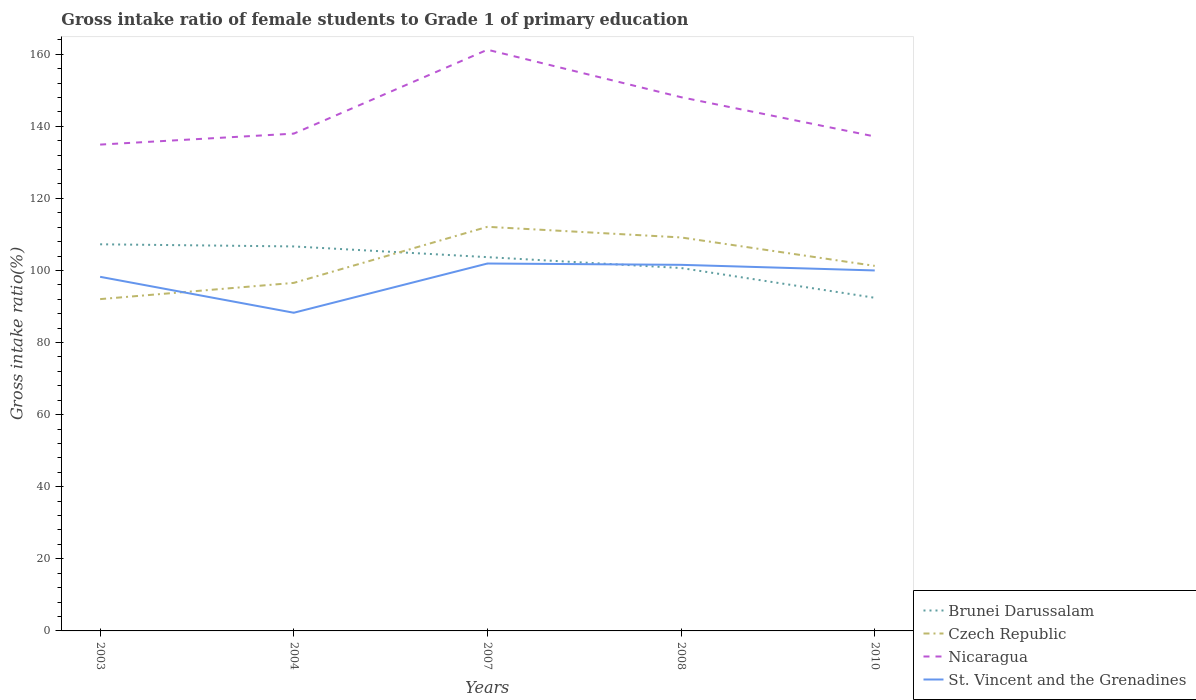Does the line corresponding to Brunei Darussalam intersect with the line corresponding to St. Vincent and the Grenadines?
Keep it short and to the point. Yes. Is the number of lines equal to the number of legend labels?
Offer a very short reply. Yes. Across all years, what is the maximum gross intake ratio in Nicaragua?
Your answer should be very brief. 134.92. What is the total gross intake ratio in Nicaragua in the graph?
Make the answer very short. 10.9. What is the difference between the highest and the second highest gross intake ratio in Nicaragua?
Keep it short and to the point. 26.32. Is the gross intake ratio in Brunei Darussalam strictly greater than the gross intake ratio in Czech Republic over the years?
Provide a short and direct response. No. How many lines are there?
Offer a very short reply. 4. What is the difference between two consecutive major ticks on the Y-axis?
Ensure brevity in your answer.  20. Does the graph contain grids?
Make the answer very short. No. How are the legend labels stacked?
Offer a very short reply. Vertical. What is the title of the graph?
Provide a short and direct response. Gross intake ratio of female students to Grade 1 of primary education. Does "Lao PDR" appear as one of the legend labels in the graph?
Provide a succinct answer. No. What is the label or title of the X-axis?
Keep it short and to the point. Years. What is the label or title of the Y-axis?
Your response must be concise. Gross intake ratio(%). What is the Gross intake ratio(%) in Brunei Darussalam in 2003?
Provide a short and direct response. 107.26. What is the Gross intake ratio(%) of Czech Republic in 2003?
Your response must be concise. 92.05. What is the Gross intake ratio(%) of Nicaragua in 2003?
Give a very brief answer. 134.92. What is the Gross intake ratio(%) of St. Vincent and the Grenadines in 2003?
Keep it short and to the point. 98.24. What is the Gross intake ratio(%) of Brunei Darussalam in 2004?
Make the answer very short. 106.66. What is the Gross intake ratio(%) in Czech Republic in 2004?
Give a very brief answer. 96.55. What is the Gross intake ratio(%) in Nicaragua in 2004?
Your response must be concise. 137.96. What is the Gross intake ratio(%) in St. Vincent and the Grenadines in 2004?
Offer a very short reply. 88.27. What is the Gross intake ratio(%) in Brunei Darussalam in 2007?
Your answer should be compact. 103.69. What is the Gross intake ratio(%) in Czech Republic in 2007?
Keep it short and to the point. 112.11. What is the Gross intake ratio(%) in Nicaragua in 2007?
Provide a succinct answer. 161.24. What is the Gross intake ratio(%) in St. Vincent and the Grenadines in 2007?
Keep it short and to the point. 101.93. What is the Gross intake ratio(%) of Brunei Darussalam in 2008?
Your answer should be compact. 100.68. What is the Gross intake ratio(%) of Czech Republic in 2008?
Provide a succinct answer. 109.16. What is the Gross intake ratio(%) in Nicaragua in 2008?
Your answer should be very brief. 148.06. What is the Gross intake ratio(%) of St. Vincent and the Grenadines in 2008?
Provide a succinct answer. 101.56. What is the Gross intake ratio(%) of Brunei Darussalam in 2010?
Your answer should be compact. 92.42. What is the Gross intake ratio(%) in Czech Republic in 2010?
Your answer should be very brief. 101.27. What is the Gross intake ratio(%) in Nicaragua in 2010?
Make the answer very short. 137.17. Across all years, what is the maximum Gross intake ratio(%) in Brunei Darussalam?
Your response must be concise. 107.26. Across all years, what is the maximum Gross intake ratio(%) in Czech Republic?
Your answer should be very brief. 112.11. Across all years, what is the maximum Gross intake ratio(%) of Nicaragua?
Make the answer very short. 161.24. Across all years, what is the maximum Gross intake ratio(%) of St. Vincent and the Grenadines?
Offer a terse response. 101.93. Across all years, what is the minimum Gross intake ratio(%) of Brunei Darussalam?
Keep it short and to the point. 92.42. Across all years, what is the minimum Gross intake ratio(%) of Czech Republic?
Give a very brief answer. 92.05. Across all years, what is the minimum Gross intake ratio(%) in Nicaragua?
Your answer should be compact. 134.92. Across all years, what is the minimum Gross intake ratio(%) in St. Vincent and the Grenadines?
Your response must be concise. 88.27. What is the total Gross intake ratio(%) of Brunei Darussalam in the graph?
Your answer should be very brief. 510.71. What is the total Gross intake ratio(%) in Czech Republic in the graph?
Offer a very short reply. 511.14. What is the total Gross intake ratio(%) of Nicaragua in the graph?
Give a very brief answer. 719.34. What is the total Gross intake ratio(%) in St. Vincent and the Grenadines in the graph?
Make the answer very short. 489.99. What is the difference between the Gross intake ratio(%) of Brunei Darussalam in 2003 and that in 2004?
Your answer should be very brief. 0.59. What is the difference between the Gross intake ratio(%) of Czech Republic in 2003 and that in 2004?
Provide a short and direct response. -4.5. What is the difference between the Gross intake ratio(%) in Nicaragua in 2003 and that in 2004?
Provide a succinct answer. -3.04. What is the difference between the Gross intake ratio(%) of St. Vincent and the Grenadines in 2003 and that in 2004?
Ensure brevity in your answer.  9.97. What is the difference between the Gross intake ratio(%) in Brunei Darussalam in 2003 and that in 2007?
Provide a short and direct response. 3.56. What is the difference between the Gross intake ratio(%) of Czech Republic in 2003 and that in 2007?
Keep it short and to the point. -20.06. What is the difference between the Gross intake ratio(%) in Nicaragua in 2003 and that in 2007?
Your answer should be compact. -26.32. What is the difference between the Gross intake ratio(%) of St. Vincent and the Grenadines in 2003 and that in 2007?
Your answer should be compact. -3.69. What is the difference between the Gross intake ratio(%) of Brunei Darussalam in 2003 and that in 2008?
Keep it short and to the point. 6.58. What is the difference between the Gross intake ratio(%) of Czech Republic in 2003 and that in 2008?
Provide a succinct answer. -17.11. What is the difference between the Gross intake ratio(%) of Nicaragua in 2003 and that in 2008?
Offer a terse response. -13.15. What is the difference between the Gross intake ratio(%) in St. Vincent and the Grenadines in 2003 and that in 2008?
Your answer should be compact. -3.32. What is the difference between the Gross intake ratio(%) in Brunei Darussalam in 2003 and that in 2010?
Your answer should be very brief. 14.84. What is the difference between the Gross intake ratio(%) in Czech Republic in 2003 and that in 2010?
Offer a terse response. -9.22. What is the difference between the Gross intake ratio(%) of Nicaragua in 2003 and that in 2010?
Give a very brief answer. -2.25. What is the difference between the Gross intake ratio(%) in St. Vincent and the Grenadines in 2003 and that in 2010?
Provide a succinct answer. -1.76. What is the difference between the Gross intake ratio(%) of Brunei Darussalam in 2004 and that in 2007?
Provide a succinct answer. 2.97. What is the difference between the Gross intake ratio(%) in Czech Republic in 2004 and that in 2007?
Your response must be concise. -15.55. What is the difference between the Gross intake ratio(%) in Nicaragua in 2004 and that in 2007?
Provide a short and direct response. -23.28. What is the difference between the Gross intake ratio(%) in St. Vincent and the Grenadines in 2004 and that in 2007?
Offer a terse response. -13.66. What is the difference between the Gross intake ratio(%) of Brunei Darussalam in 2004 and that in 2008?
Make the answer very short. 5.99. What is the difference between the Gross intake ratio(%) in Czech Republic in 2004 and that in 2008?
Offer a very short reply. -12.6. What is the difference between the Gross intake ratio(%) in Nicaragua in 2004 and that in 2008?
Make the answer very short. -10.1. What is the difference between the Gross intake ratio(%) of St. Vincent and the Grenadines in 2004 and that in 2008?
Ensure brevity in your answer.  -13.29. What is the difference between the Gross intake ratio(%) of Brunei Darussalam in 2004 and that in 2010?
Make the answer very short. 14.24. What is the difference between the Gross intake ratio(%) in Czech Republic in 2004 and that in 2010?
Your response must be concise. -4.72. What is the difference between the Gross intake ratio(%) in Nicaragua in 2004 and that in 2010?
Give a very brief answer. 0.79. What is the difference between the Gross intake ratio(%) in St. Vincent and the Grenadines in 2004 and that in 2010?
Your answer should be compact. -11.73. What is the difference between the Gross intake ratio(%) of Brunei Darussalam in 2007 and that in 2008?
Your answer should be compact. 3.02. What is the difference between the Gross intake ratio(%) of Czech Republic in 2007 and that in 2008?
Offer a terse response. 2.95. What is the difference between the Gross intake ratio(%) in Nicaragua in 2007 and that in 2008?
Make the answer very short. 13.17. What is the difference between the Gross intake ratio(%) of St. Vincent and the Grenadines in 2007 and that in 2008?
Your answer should be very brief. 0.36. What is the difference between the Gross intake ratio(%) in Brunei Darussalam in 2007 and that in 2010?
Your answer should be very brief. 11.27. What is the difference between the Gross intake ratio(%) of Czech Republic in 2007 and that in 2010?
Your answer should be compact. 10.83. What is the difference between the Gross intake ratio(%) in Nicaragua in 2007 and that in 2010?
Offer a terse response. 24.07. What is the difference between the Gross intake ratio(%) of St. Vincent and the Grenadines in 2007 and that in 2010?
Give a very brief answer. 1.93. What is the difference between the Gross intake ratio(%) of Brunei Darussalam in 2008 and that in 2010?
Offer a terse response. 8.26. What is the difference between the Gross intake ratio(%) of Czech Republic in 2008 and that in 2010?
Your answer should be very brief. 7.88. What is the difference between the Gross intake ratio(%) of Nicaragua in 2008 and that in 2010?
Offer a terse response. 10.9. What is the difference between the Gross intake ratio(%) in St. Vincent and the Grenadines in 2008 and that in 2010?
Offer a terse response. 1.56. What is the difference between the Gross intake ratio(%) of Brunei Darussalam in 2003 and the Gross intake ratio(%) of Czech Republic in 2004?
Your answer should be very brief. 10.71. What is the difference between the Gross intake ratio(%) of Brunei Darussalam in 2003 and the Gross intake ratio(%) of Nicaragua in 2004?
Your response must be concise. -30.7. What is the difference between the Gross intake ratio(%) in Brunei Darussalam in 2003 and the Gross intake ratio(%) in St. Vincent and the Grenadines in 2004?
Provide a short and direct response. 18.99. What is the difference between the Gross intake ratio(%) of Czech Republic in 2003 and the Gross intake ratio(%) of Nicaragua in 2004?
Provide a short and direct response. -45.91. What is the difference between the Gross intake ratio(%) of Czech Republic in 2003 and the Gross intake ratio(%) of St. Vincent and the Grenadines in 2004?
Offer a terse response. 3.78. What is the difference between the Gross intake ratio(%) of Nicaragua in 2003 and the Gross intake ratio(%) of St. Vincent and the Grenadines in 2004?
Provide a short and direct response. 46.65. What is the difference between the Gross intake ratio(%) in Brunei Darussalam in 2003 and the Gross intake ratio(%) in Czech Republic in 2007?
Offer a terse response. -4.85. What is the difference between the Gross intake ratio(%) in Brunei Darussalam in 2003 and the Gross intake ratio(%) in Nicaragua in 2007?
Ensure brevity in your answer.  -53.98. What is the difference between the Gross intake ratio(%) of Brunei Darussalam in 2003 and the Gross intake ratio(%) of St. Vincent and the Grenadines in 2007?
Your answer should be very brief. 5.33. What is the difference between the Gross intake ratio(%) of Czech Republic in 2003 and the Gross intake ratio(%) of Nicaragua in 2007?
Offer a very short reply. -69.19. What is the difference between the Gross intake ratio(%) in Czech Republic in 2003 and the Gross intake ratio(%) in St. Vincent and the Grenadines in 2007?
Keep it short and to the point. -9.88. What is the difference between the Gross intake ratio(%) in Nicaragua in 2003 and the Gross intake ratio(%) in St. Vincent and the Grenadines in 2007?
Your answer should be compact. 32.99. What is the difference between the Gross intake ratio(%) in Brunei Darussalam in 2003 and the Gross intake ratio(%) in Czech Republic in 2008?
Provide a short and direct response. -1.9. What is the difference between the Gross intake ratio(%) of Brunei Darussalam in 2003 and the Gross intake ratio(%) of Nicaragua in 2008?
Offer a very short reply. -40.81. What is the difference between the Gross intake ratio(%) in Brunei Darussalam in 2003 and the Gross intake ratio(%) in St. Vincent and the Grenadines in 2008?
Make the answer very short. 5.7. What is the difference between the Gross intake ratio(%) in Czech Republic in 2003 and the Gross intake ratio(%) in Nicaragua in 2008?
Provide a succinct answer. -56.01. What is the difference between the Gross intake ratio(%) in Czech Republic in 2003 and the Gross intake ratio(%) in St. Vincent and the Grenadines in 2008?
Provide a succinct answer. -9.51. What is the difference between the Gross intake ratio(%) in Nicaragua in 2003 and the Gross intake ratio(%) in St. Vincent and the Grenadines in 2008?
Keep it short and to the point. 33.36. What is the difference between the Gross intake ratio(%) in Brunei Darussalam in 2003 and the Gross intake ratio(%) in Czech Republic in 2010?
Offer a terse response. 5.99. What is the difference between the Gross intake ratio(%) of Brunei Darussalam in 2003 and the Gross intake ratio(%) of Nicaragua in 2010?
Your answer should be compact. -29.91. What is the difference between the Gross intake ratio(%) in Brunei Darussalam in 2003 and the Gross intake ratio(%) in St. Vincent and the Grenadines in 2010?
Offer a terse response. 7.26. What is the difference between the Gross intake ratio(%) in Czech Republic in 2003 and the Gross intake ratio(%) in Nicaragua in 2010?
Make the answer very short. -45.12. What is the difference between the Gross intake ratio(%) in Czech Republic in 2003 and the Gross intake ratio(%) in St. Vincent and the Grenadines in 2010?
Provide a succinct answer. -7.95. What is the difference between the Gross intake ratio(%) in Nicaragua in 2003 and the Gross intake ratio(%) in St. Vincent and the Grenadines in 2010?
Keep it short and to the point. 34.92. What is the difference between the Gross intake ratio(%) in Brunei Darussalam in 2004 and the Gross intake ratio(%) in Czech Republic in 2007?
Keep it short and to the point. -5.44. What is the difference between the Gross intake ratio(%) of Brunei Darussalam in 2004 and the Gross intake ratio(%) of Nicaragua in 2007?
Provide a short and direct response. -54.57. What is the difference between the Gross intake ratio(%) of Brunei Darussalam in 2004 and the Gross intake ratio(%) of St. Vincent and the Grenadines in 2007?
Offer a terse response. 4.74. What is the difference between the Gross intake ratio(%) in Czech Republic in 2004 and the Gross intake ratio(%) in Nicaragua in 2007?
Your answer should be very brief. -64.68. What is the difference between the Gross intake ratio(%) in Czech Republic in 2004 and the Gross intake ratio(%) in St. Vincent and the Grenadines in 2007?
Provide a succinct answer. -5.37. What is the difference between the Gross intake ratio(%) of Nicaragua in 2004 and the Gross intake ratio(%) of St. Vincent and the Grenadines in 2007?
Offer a very short reply. 36.03. What is the difference between the Gross intake ratio(%) in Brunei Darussalam in 2004 and the Gross intake ratio(%) in Czech Republic in 2008?
Your answer should be very brief. -2.49. What is the difference between the Gross intake ratio(%) in Brunei Darussalam in 2004 and the Gross intake ratio(%) in Nicaragua in 2008?
Offer a terse response. -41.4. What is the difference between the Gross intake ratio(%) of Brunei Darussalam in 2004 and the Gross intake ratio(%) of St. Vincent and the Grenadines in 2008?
Offer a very short reply. 5.1. What is the difference between the Gross intake ratio(%) in Czech Republic in 2004 and the Gross intake ratio(%) in Nicaragua in 2008?
Your answer should be compact. -51.51. What is the difference between the Gross intake ratio(%) in Czech Republic in 2004 and the Gross intake ratio(%) in St. Vincent and the Grenadines in 2008?
Offer a terse response. -5.01. What is the difference between the Gross intake ratio(%) of Nicaragua in 2004 and the Gross intake ratio(%) of St. Vincent and the Grenadines in 2008?
Provide a short and direct response. 36.4. What is the difference between the Gross intake ratio(%) in Brunei Darussalam in 2004 and the Gross intake ratio(%) in Czech Republic in 2010?
Your answer should be very brief. 5.39. What is the difference between the Gross intake ratio(%) of Brunei Darussalam in 2004 and the Gross intake ratio(%) of Nicaragua in 2010?
Provide a succinct answer. -30.5. What is the difference between the Gross intake ratio(%) of Brunei Darussalam in 2004 and the Gross intake ratio(%) of St. Vincent and the Grenadines in 2010?
Keep it short and to the point. 6.66. What is the difference between the Gross intake ratio(%) of Czech Republic in 2004 and the Gross intake ratio(%) of Nicaragua in 2010?
Your response must be concise. -40.61. What is the difference between the Gross intake ratio(%) of Czech Republic in 2004 and the Gross intake ratio(%) of St. Vincent and the Grenadines in 2010?
Provide a succinct answer. -3.45. What is the difference between the Gross intake ratio(%) in Nicaragua in 2004 and the Gross intake ratio(%) in St. Vincent and the Grenadines in 2010?
Give a very brief answer. 37.96. What is the difference between the Gross intake ratio(%) in Brunei Darussalam in 2007 and the Gross intake ratio(%) in Czech Republic in 2008?
Make the answer very short. -5.46. What is the difference between the Gross intake ratio(%) of Brunei Darussalam in 2007 and the Gross intake ratio(%) of Nicaragua in 2008?
Offer a terse response. -44.37. What is the difference between the Gross intake ratio(%) in Brunei Darussalam in 2007 and the Gross intake ratio(%) in St. Vincent and the Grenadines in 2008?
Keep it short and to the point. 2.13. What is the difference between the Gross intake ratio(%) of Czech Republic in 2007 and the Gross intake ratio(%) of Nicaragua in 2008?
Make the answer very short. -35.96. What is the difference between the Gross intake ratio(%) in Czech Republic in 2007 and the Gross intake ratio(%) in St. Vincent and the Grenadines in 2008?
Keep it short and to the point. 10.55. What is the difference between the Gross intake ratio(%) of Nicaragua in 2007 and the Gross intake ratio(%) of St. Vincent and the Grenadines in 2008?
Give a very brief answer. 59.67. What is the difference between the Gross intake ratio(%) of Brunei Darussalam in 2007 and the Gross intake ratio(%) of Czech Republic in 2010?
Ensure brevity in your answer.  2.42. What is the difference between the Gross intake ratio(%) in Brunei Darussalam in 2007 and the Gross intake ratio(%) in Nicaragua in 2010?
Provide a short and direct response. -33.47. What is the difference between the Gross intake ratio(%) in Brunei Darussalam in 2007 and the Gross intake ratio(%) in St. Vincent and the Grenadines in 2010?
Make the answer very short. 3.69. What is the difference between the Gross intake ratio(%) in Czech Republic in 2007 and the Gross intake ratio(%) in Nicaragua in 2010?
Your answer should be very brief. -25.06. What is the difference between the Gross intake ratio(%) of Czech Republic in 2007 and the Gross intake ratio(%) of St. Vincent and the Grenadines in 2010?
Give a very brief answer. 12.11. What is the difference between the Gross intake ratio(%) of Nicaragua in 2007 and the Gross intake ratio(%) of St. Vincent and the Grenadines in 2010?
Offer a terse response. 61.24. What is the difference between the Gross intake ratio(%) in Brunei Darussalam in 2008 and the Gross intake ratio(%) in Czech Republic in 2010?
Your answer should be very brief. -0.6. What is the difference between the Gross intake ratio(%) in Brunei Darussalam in 2008 and the Gross intake ratio(%) in Nicaragua in 2010?
Keep it short and to the point. -36.49. What is the difference between the Gross intake ratio(%) in Brunei Darussalam in 2008 and the Gross intake ratio(%) in St. Vincent and the Grenadines in 2010?
Ensure brevity in your answer.  0.68. What is the difference between the Gross intake ratio(%) in Czech Republic in 2008 and the Gross intake ratio(%) in Nicaragua in 2010?
Make the answer very short. -28.01. What is the difference between the Gross intake ratio(%) in Czech Republic in 2008 and the Gross intake ratio(%) in St. Vincent and the Grenadines in 2010?
Provide a succinct answer. 9.16. What is the difference between the Gross intake ratio(%) of Nicaragua in 2008 and the Gross intake ratio(%) of St. Vincent and the Grenadines in 2010?
Keep it short and to the point. 48.06. What is the average Gross intake ratio(%) of Brunei Darussalam per year?
Provide a succinct answer. 102.14. What is the average Gross intake ratio(%) in Czech Republic per year?
Your answer should be very brief. 102.23. What is the average Gross intake ratio(%) in Nicaragua per year?
Ensure brevity in your answer.  143.87. What is the average Gross intake ratio(%) in St. Vincent and the Grenadines per year?
Your answer should be very brief. 98. In the year 2003, what is the difference between the Gross intake ratio(%) in Brunei Darussalam and Gross intake ratio(%) in Czech Republic?
Your answer should be compact. 15.21. In the year 2003, what is the difference between the Gross intake ratio(%) of Brunei Darussalam and Gross intake ratio(%) of Nicaragua?
Your answer should be compact. -27.66. In the year 2003, what is the difference between the Gross intake ratio(%) in Brunei Darussalam and Gross intake ratio(%) in St. Vincent and the Grenadines?
Your answer should be compact. 9.02. In the year 2003, what is the difference between the Gross intake ratio(%) of Czech Republic and Gross intake ratio(%) of Nicaragua?
Make the answer very short. -42.87. In the year 2003, what is the difference between the Gross intake ratio(%) in Czech Republic and Gross intake ratio(%) in St. Vincent and the Grenadines?
Provide a succinct answer. -6.19. In the year 2003, what is the difference between the Gross intake ratio(%) of Nicaragua and Gross intake ratio(%) of St. Vincent and the Grenadines?
Make the answer very short. 36.68. In the year 2004, what is the difference between the Gross intake ratio(%) in Brunei Darussalam and Gross intake ratio(%) in Czech Republic?
Offer a very short reply. 10.11. In the year 2004, what is the difference between the Gross intake ratio(%) of Brunei Darussalam and Gross intake ratio(%) of Nicaragua?
Offer a terse response. -31.3. In the year 2004, what is the difference between the Gross intake ratio(%) of Brunei Darussalam and Gross intake ratio(%) of St. Vincent and the Grenadines?
Provide a succinct answer. 18.4. In the year 2004, what is the difference between the Gross intake ratio(%) in Czech Republic and Gross intake ratio(%) in Nicaragua?
Provide a short and direct response. -41.41. In the year 2004, what is the difference between the Gross intake ratio(%) of Czech Republic and Gross intake ratio(%) of St. Vincent and the Grenadines?
Provide a short and direct response. 8.28. In the year 2004, what is the difference between the Gross intake ratio(%) in Nicaragua and Gross intake ratio(%) in St. Vincent and the Grenadines?
Keep it short and to the point. 49.69. In the year 2007, what is the difference between the Gross intake ratio(%) of Brunei Darussalam and Gross intake ratio(%) of Czech Republic?
Offer a very short reply. -8.41. In the year 2007, what is the difference between the Gross intake ratio(%) of Brunei Darussalam and Gross intake ratio(%) of Nicaragua?
Make the answer very short. -57.54. In the year 2007, what is the difference between the Gross intake ratio(%) in Brunei Darussalam and Gross intake ratio(%) in St. Vincent and the Grenadines?
Give a very brief answer. 1.77. In the year 2007, what is the difference between the Gross intake ratio(%) of Czech Republic and Gross intake ratio(%) of Nicaragua?
Offer a terse response. -49.13. In the year 2007, what is the difference between the Gross intake ratio(%) of Czech Republic and Gross intake ratio(%) of St. Vincent and the Grenadines?
Your response must be concise. 10.18. In the year 2007, what is the difference between the Gross intake ratio(%) in Nicaragua and Gross intake ratio(%) in St. Vincent and the Grenadines?
Make the answer very short. 59.31. In the year 2008, what is the difference between the Gross intake ratio(%) of Brunei Darussalam and Gross intake ratio(%) of Czech Republic?
Your answer should be compact. -8.48. In the year 2008, what is the difference between the Gross intake ratio(%) of Brunei Darussalam and Gross intake ratio(%) of Nicaragua?
Keep it short and to the point. -47.39. In the year 2008, what is the difference between the Gross intake ratio(%) in Brunei Darussalam and Gross intake ratio(%) in St. Vincent and the Grenadines?
Provide a succinct answer. -0.88. In the year 2008, what is the difference between the Gross intake ratio(%) of Czech Republic and Gross intake ratio(%) of Nicaragua?
Your response must be concise. -38.91. In the year 2008, what is the difference between the Gross intake ratio(%) in Czech Republic and Gross intake ratio(%) in St. Vincent and the Grenadines?
Keep it short and to the point. 7.6. In the year 2008, what is the difference between the Gross intake ratio(%) of Nicaragua and Gross intake ratio(%) of St. Vincent and the Grenadines?
Your answer should be compact. 46.5. In the year 2010, what is the difference between the Gross intake ratio(%) in Brunei Darussalam and Gross intake ratio(%) in Czech Republic?
Ensure brevity in your answer.  -8.85. In the year 2010, what is the difference between the Gross intake ratio(%) in Brunei Darussalam and Gross intake ratio(%) in Nicaragua?
Provide a short and direct response. -44.75. In the year 2010, what is the difference between the Gross intake ratio(%) of Brunei Darussalam and Gross intake ratio(%) of St. Vincent and the Grenadines?
Offer a terse response. -7.58. In the year 2010, what is the difference between the Gross intake ratio(%) in Czech Republic and Gross intake ratio(%) in Nicaragua?
Provide a succinct answer. -35.89. In the year 2010, what is the difference between the Gross intake ratio(%) in Czech Republic and Gross intake ratio(%) in St. Vincent and the Grenadines?
Make the answer very short. 1.27. In the year 2010, what is the difference between the Gross intake ratio(%) in Nicaragua and Gross intake ratio(%) in St. Vincent and the Grenadines?
Your response must be concise. 37.17. What is the ratio of the Gross intake ratio(%) of Brunei Darussalam in 2003 to that in 2004?
Make the answer very short. 1.01. What is the ratio of the Gross intake ratio(%) of Czech Republic in 2003 to that in 2004?
Keep it short and to the point. 0.95. What is the ratio of the Gross intake ratio(%) of St. Vincent and the Grenadines in 2003 to that in 2004?
Ensure brevity in your answer.  1.11. What is the ratio of the Gross intake ratio(%) in Brunei Darussalam in 2003 to that in 2007?
Provide a short and direct response. 1.03. What is the ratio of the Gross intake ratio(%) of Czech Republic in 2003 to that in 2007?
Provide a short and direct response. 0.82. What is the ratio of the Gross intake ratio(%) in Nicaragua in 2003 to that in 2007?
Provide a succinct answer. 0.84. What is the ratio of the Gross intake ratio(%) in St. Vincent and the Grenadines in 2003 to that in 2007?
Provide a succinct answer. 0.96. What is the ratio of the Gross intake ratio(%) of Brunei Darussalam in 2003 to that in 2008?
Your answer should be very brief. 1.07. What is the ratio of the Gross intake ratio(%) of Czech Republic in 2003 to that in 2008?
Provide a succinct answer. 0.84. What is the ratio of the Gross intake ratio(%) in Nicaragua in 2003 to that in 2008?
Your answer should be compact. 0.91. What is the ratio of the Gross intake ratio(%) of St. Vincent and the Grenadines in 2003 to that in 2008?
Ensure brevity in your answer.  0.97. What is the ratio of the Gross intake ratio(%) in Brunei Darussalam in 2003 to that in 2010?
Your answer should be compact. 1.16. What is the ratio of the Gross intake ratio(%) of Czech Republic in 2003 to that in 2010?
Make the answer very short. 0.91. What is the ratio of the Gross intake ratio(%) of Nicaragua in 2003 to that in 2010?
Make the answer very short. 0.98. What is the ratio of the Gross intake ratio(%) of St. Vincent and the Grenadines in 2003 to that in 2010?
Give a very brief answer. 0.98. What is the ratio of the Gross intake ratio(%) of Brunei Darussalam in 2004 to that in 2007?
Keep it short and to the point. 1.03. What is the ratio of the Gross intake ratio(%) in Czech Republic in 2004 to that in 2007?
Your answer should be very brief. 0.86. What is the ratio of the Gross intake ratio(%) in Nicaragua in 2004 to that in 2007?
Provide a succinct answer. 0.86. What is the ratio of the Gross intake ratio(%) in St. Vincent and the Grenadines in 2004 to that in 2007?
Offer a very short reply. 0.87. What is the ratio of the Gross intake ratio(%) of Brunei Darussalam in 2004 to that in 2008?
Give a very brief answer. 1.06. What is the ratio of the Gross intake ratio(%) in Czech Republic in 2004 to that in 2008?
Provide a succinct answer. 0.88. What is the ratio of the Gross intake ratio(%) of Nicaragua in 2004 to that in 2008?
Offer a terse response. 0.93. What is the ratio of the Gross intake ratio(%) in St. Vincent and the Grenadines in 2004 to that in 2008?
Make the answer very short. 0.87. What is the ratio of the Gross intake ratio(%) of Brunei Darussalam in 2004 to that in 2010?
Provide a succinct answer. 1.15. What is the ratio of the Gross intake ratio(%) of Czech Republic in 2004 to that in 2010?
Ensure brevity in your answer.  0.95. What is the ratio of the Gross intake ratio(%) of St. Vincent and the Grenadines in 2004 to that in 2010?
Your answer should be very brief. 0.88. What is the ratio of the Gross intake ratio(%) of Nicaragua in 2007 to that in 2008?
Your answer should be compact. 1.09. What is the ratio of the Gross intake ratio(%) in Brunei Darussalam in 2007 to that in 2010?
Your answer should be very brief. 1.12. What is the ratio of the Gross intake ratio(%) in Czech Republic in 2007 to that in 2010?
Offer a very short reply. 1.11. What is the ratio of the Gross intake ratio(%) in Nicaragua in 2007 to that in 2010?
Make the answer very short. 1.18. What is the ratio of the Gross intake ratio(%) of St. Vincent and the Grenadines in 2007 to that in 2010?
Offer a terse response. 1.02. What is the ratio of the Gross intake ratio(%) of Brunei Darussalam in 2008 to that in 2010?
Your answer should be very brief. 1.09. What is the ratio of the Gross intake ratio(%) of Czech Republic in 2008 to that in 2010?
Give a very brief answer. 1.08. What is the ratio of the Gross intake ratio(%) of Nicaragua in 2008 to that in 2010?
Give a very brief answer. 1.08. What is the ratio of the Gross intake ratio(%) of St. Vincent and the Grenadines in 2008 to that in 2010?
Offer a very short reply. 1.02. What is the difference between the highest and the second highest Gross intake ratio(%) in Brunei Darussalam?
Provide a short and direct response. 0.59. What is the difference between the highest and the second highest Gross intake ratio(%) of Czech Republic?
Ensure brevity in your answer.  2.95. What is the difference between the highest and the second highest Gross intake ratio(%) in Nicaragua?
Offer a terse response. 13.17. What is the difference between the highest and the second highest Gross intake ratio(%) in St. Vincent and the Grenadines?
Your answer should be very brief. 0.36. What is the difference between the highest and the lowest Gross intake ratio(%) of Brunei Darussalam?
Make the answer very short. 14.84. What is the difference between the highest and the lowest Gross intake ratio(%) in Czech Republic?
Your answer should be compact. 20.06. What is the difference between the highest and the lowest Gross intake ratio(%) of Nicaragua?
Make the answer very short. 26.32. What is the difference between the highest and the lowest Gross intake ratio(%) of St. Vincent and the Grenadines?
Offer a terse response. 13.66. 